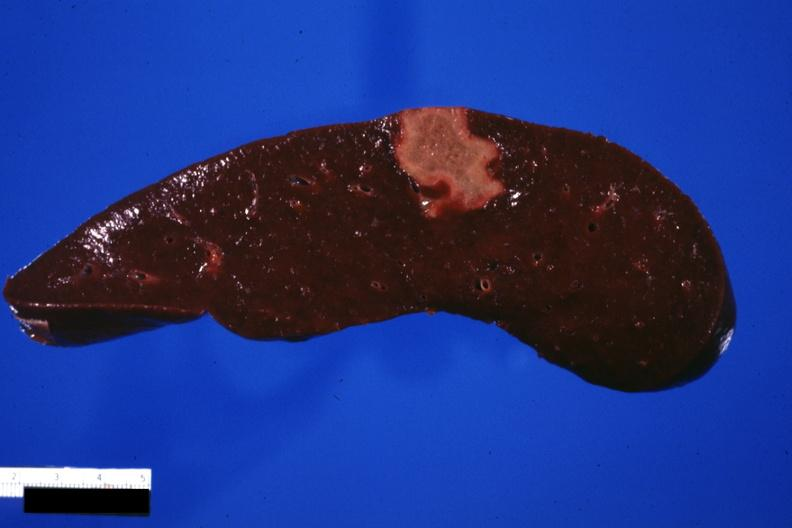does very good example show cut surface of spleen with an infarct several days of age excellent photo?
Answer the question using a single word or phrase. No 